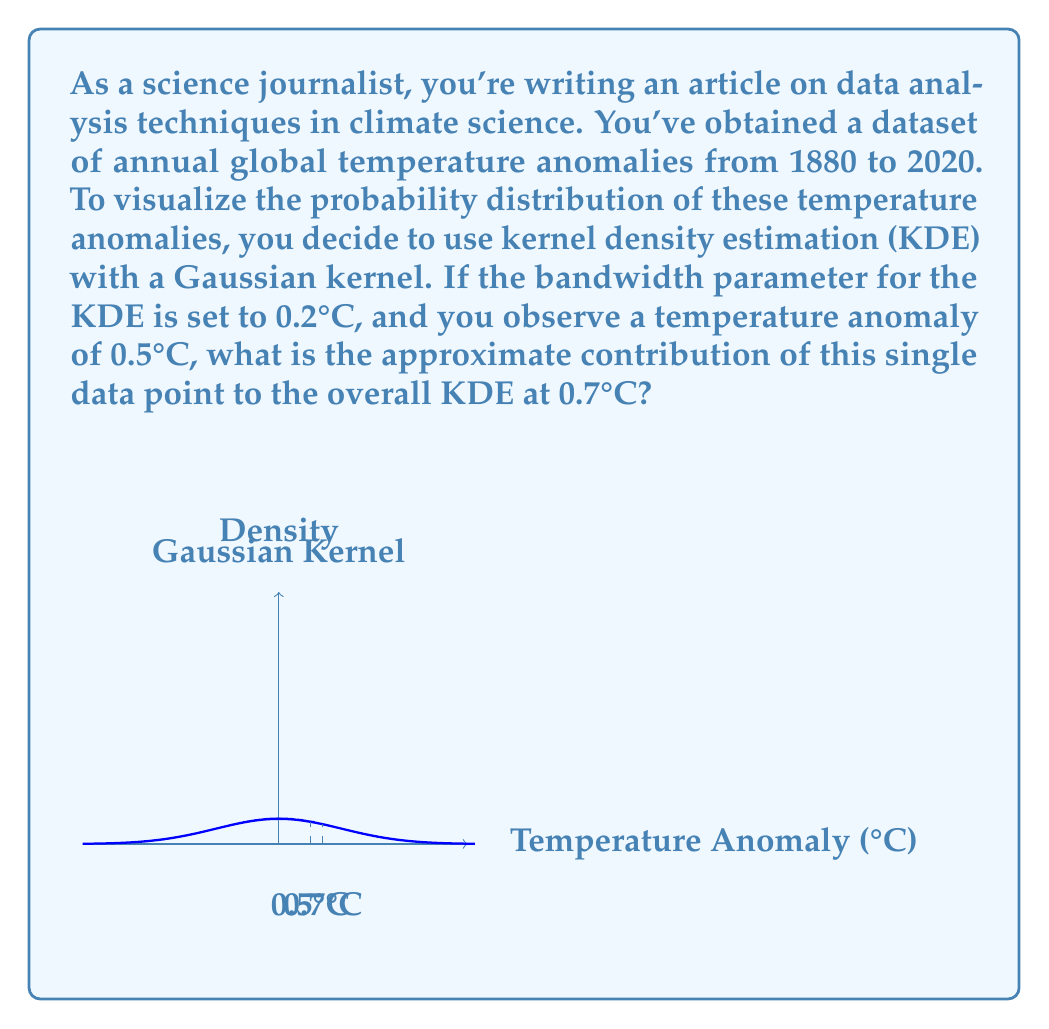Provide a solution to this math problem. To solve this problem, we need to understand the principles of kernel density estimation (KDE) and apply them to the given scenario. Let's break it down step-by-step:

1) In KDE with a Gaussian kernel, each data point contributes a Gaussian curve to the overall density estimate. The bandwidth parameter determines the width of these Gaussian curves.

2) The Gaussian kernel function is given by:

   $$K(x) = \frac{1}{\sqrt{2\pi}} e^{-\frac{x^2}{2}}$$

3) In our case, we need to account for the bandwidth (h = 0.2°C) and the distance between the observed point (0.5°C) and the point of interest (0.7°C). The scaled kernel function becomes:

   $$K_h(x) = \frac{1}{h} K(\frac{x}{h}) = \frac{1}{0.2\sqrt{2\pi}} e^{-\frac{1}{2}(\frac{x}{0.2})^2}$$

4) The distance between the observed point and the point of interest is:
   
   $$x = 0.7°C - 0.5°C = 0.2°C$$

5) Now, let's plug this into our scaled kernel function:

   $$K_h(0.2) = \frac{1}{0.2\sqrt{2\pi}} e^{-\frac{1}{2}(\frac{0.2}{0.2})^2}$$

6) Simplify:

   $$K_h(0.2) = \frac{1}{0.2\sqrt{2\pi}} e^{-\frac{1}{2}}$$

7) Calculate the result:

   $$K_h(0.2) \approx 1.5957$$

8) This value represents the contribution of the single data point at 0.5°C to the overall KDE at 0.7°C.

Note that in a full KDE, this process would be repeated for all data points, and the results would be summed to get the final density estimate at 0.7°C.
Answer: $1.5957$ 